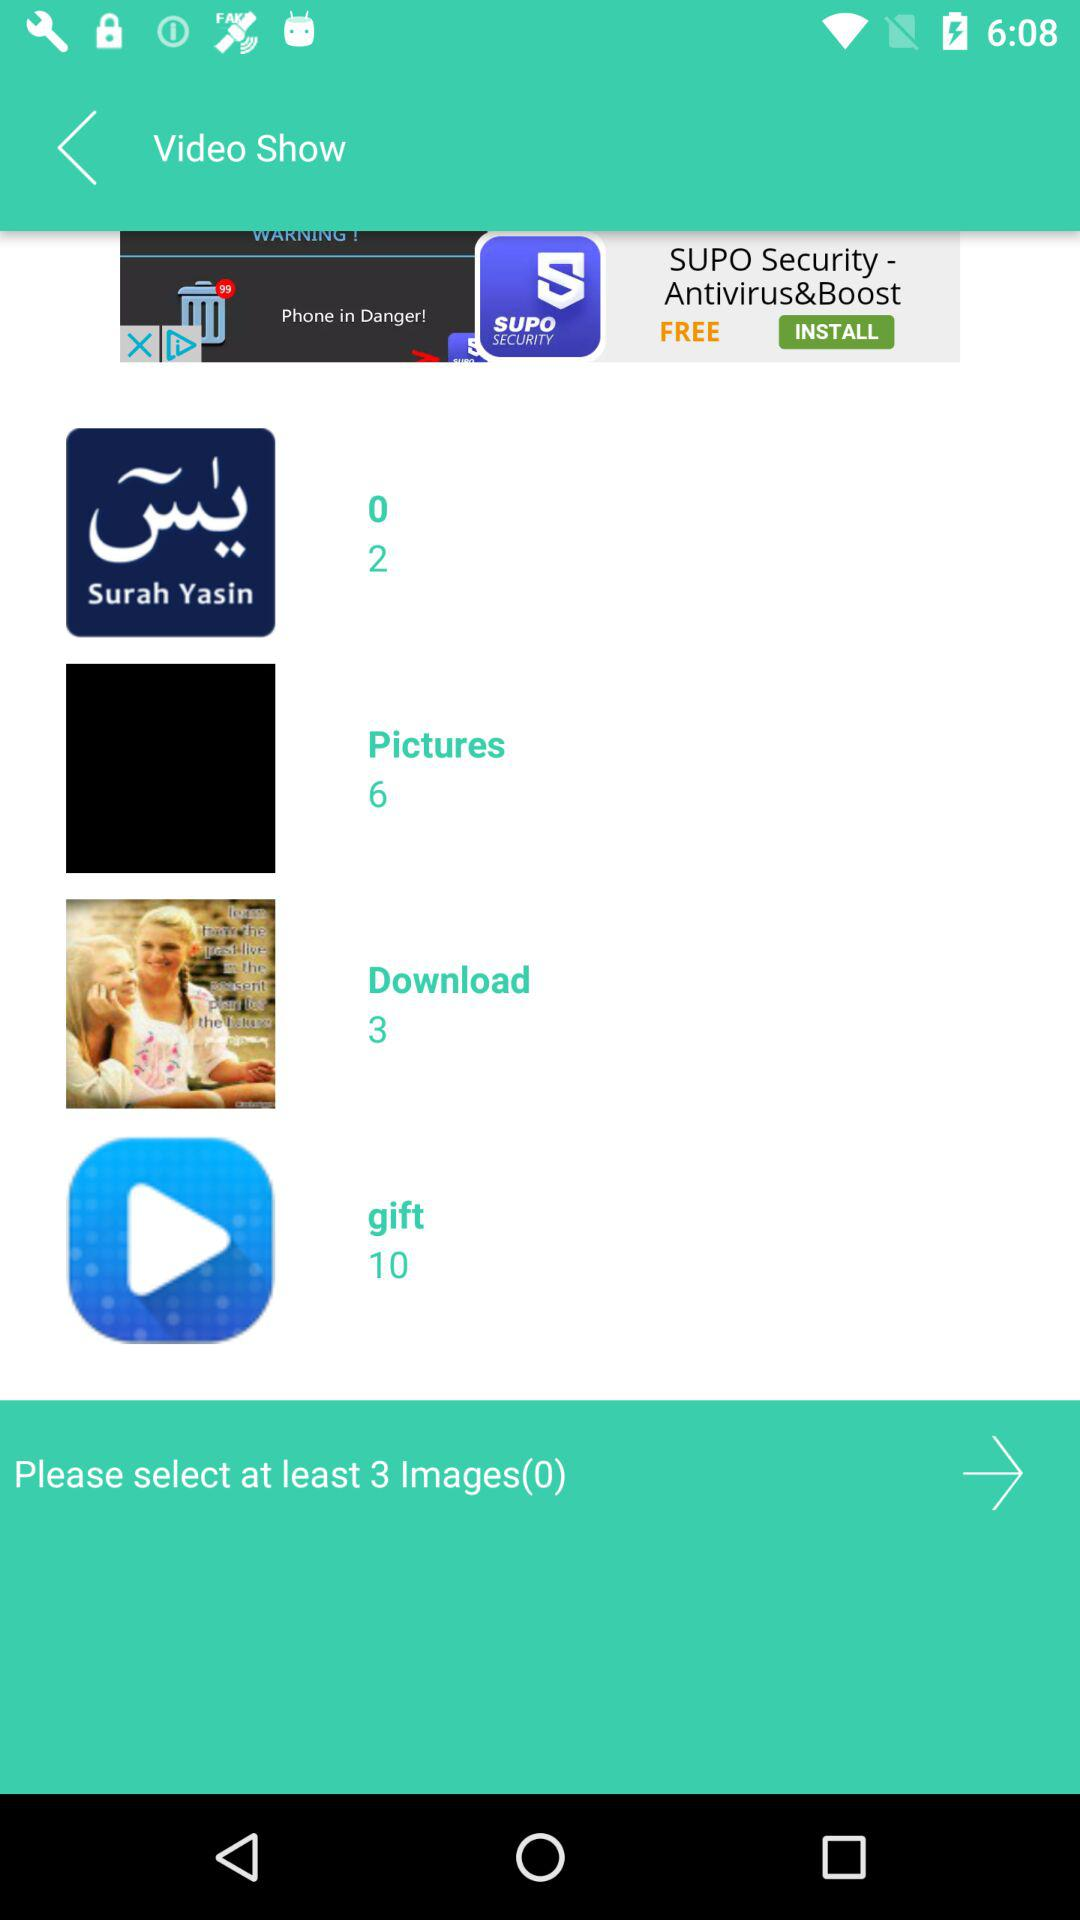How many images in total are there in the "Download" folder? There are 3 images in the "Download" folder. 